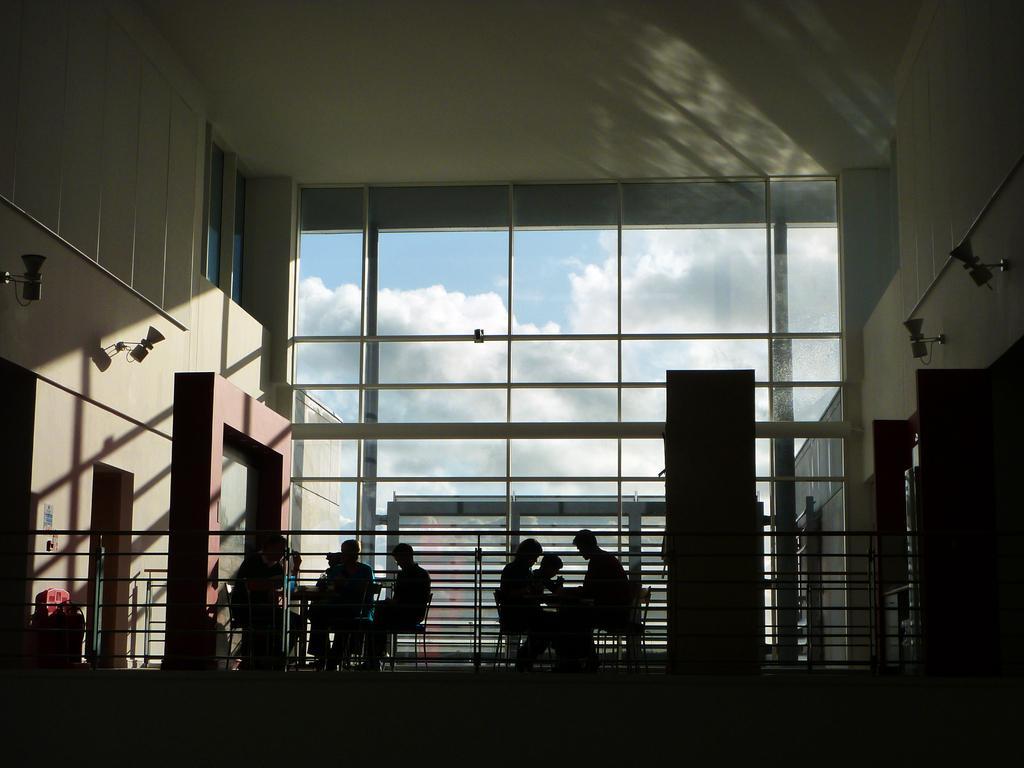How would you summarize this image in a sentence or two? In this image I can see the inner part of the building and I can see few persons sitting, few lights, railing. I can also see the glass wall, background the sky is in blue and white color. 